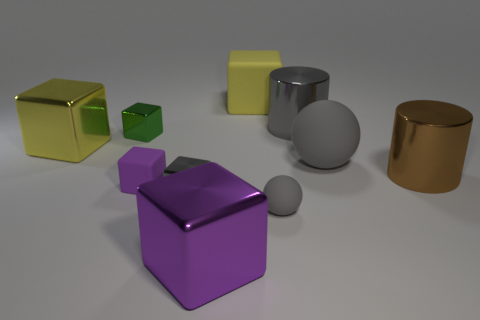How many cyan matte cylinders are the same size as the brown metallic object?
Your answer should be compact. 0. How many yellow metal objects are in front of the small purple block?
Make the answer very short. 0. What is the gray thing that is behind the big yellow object that is on the left side of the big yellow rubber cube made of?
Keep it short and to the point. Metal. Is there a metallic cube that has the same color as the tiny ball?
Keep it short and to the point. Yes. What size is the purple thing that is the same material as the large sphere?
Your answer should be compact. Small. Is there anything else that is the same color as the large sphere?
Provide a succinct answer. Yes. There is a rubber thing behind the green block; what color is it?
Keep it short and to the point. Yellow. There is a big yellow thing that is left of the yellow block right of the purple matte block; are there any big purple metal things on the right side of it?
Offer a terse response. Yes. Are there more gray rubber things that are in front of the green block than purple metal cubes?
Ensure brevity in your answer.  Yes. There is a small thing to the right of the small gray shiny object; is it the same shape as the large purple metallic thing?
Provide a succinct answer. No. 